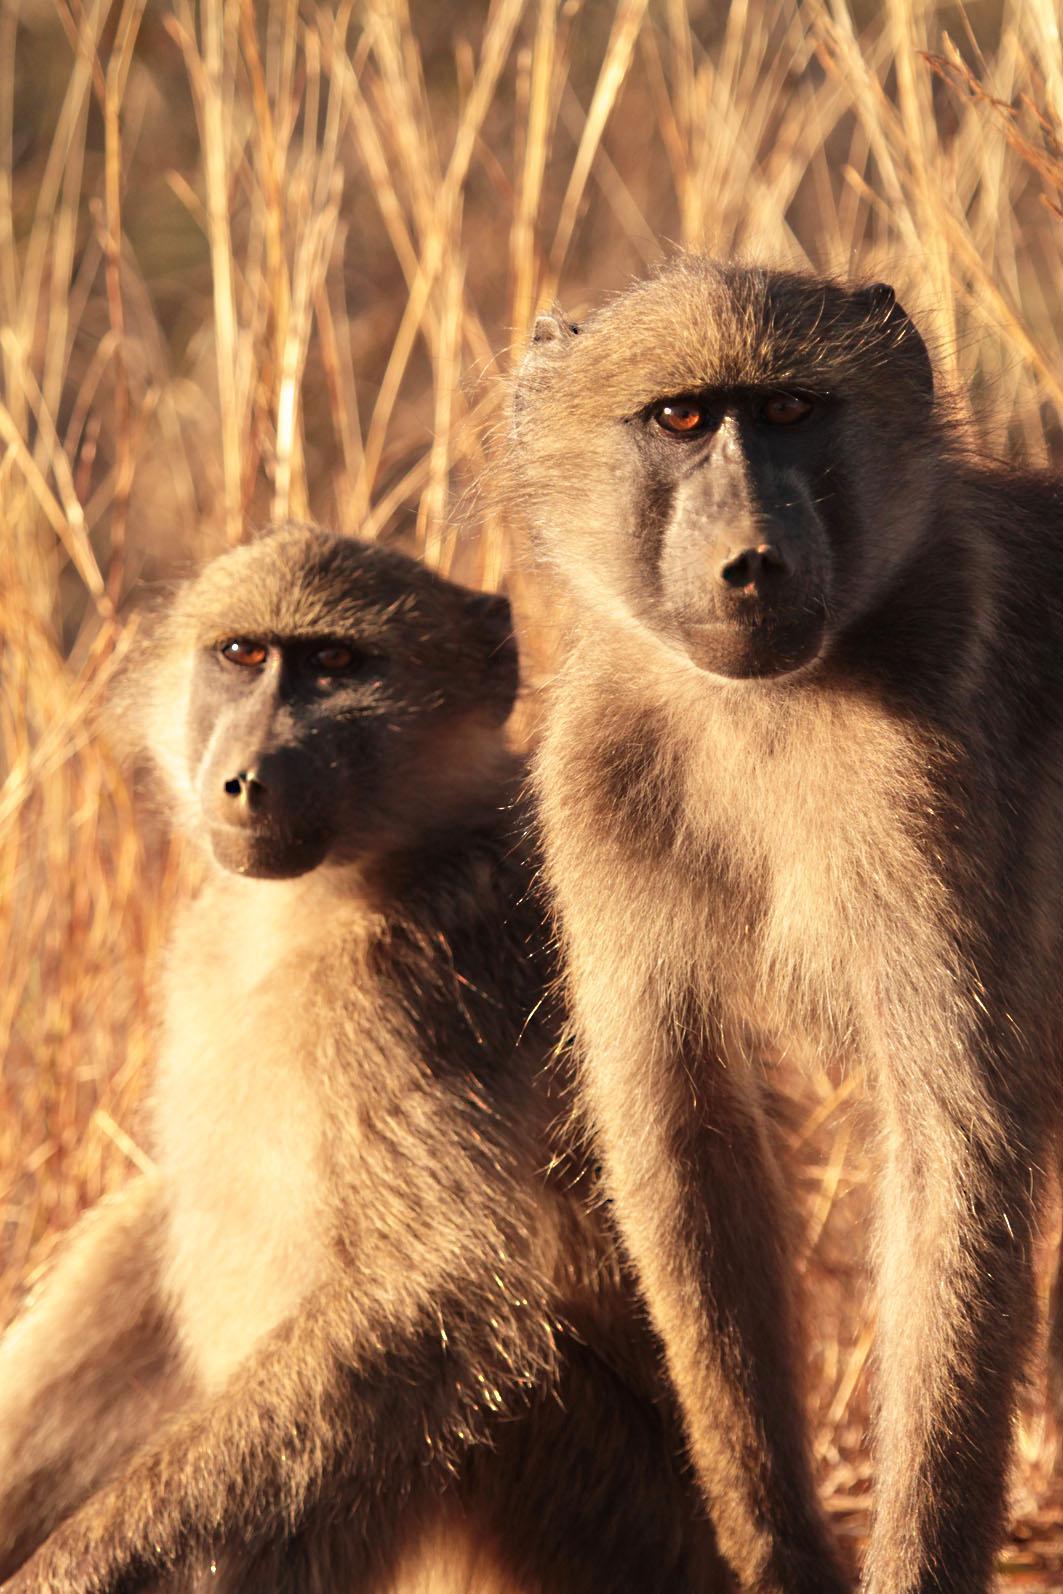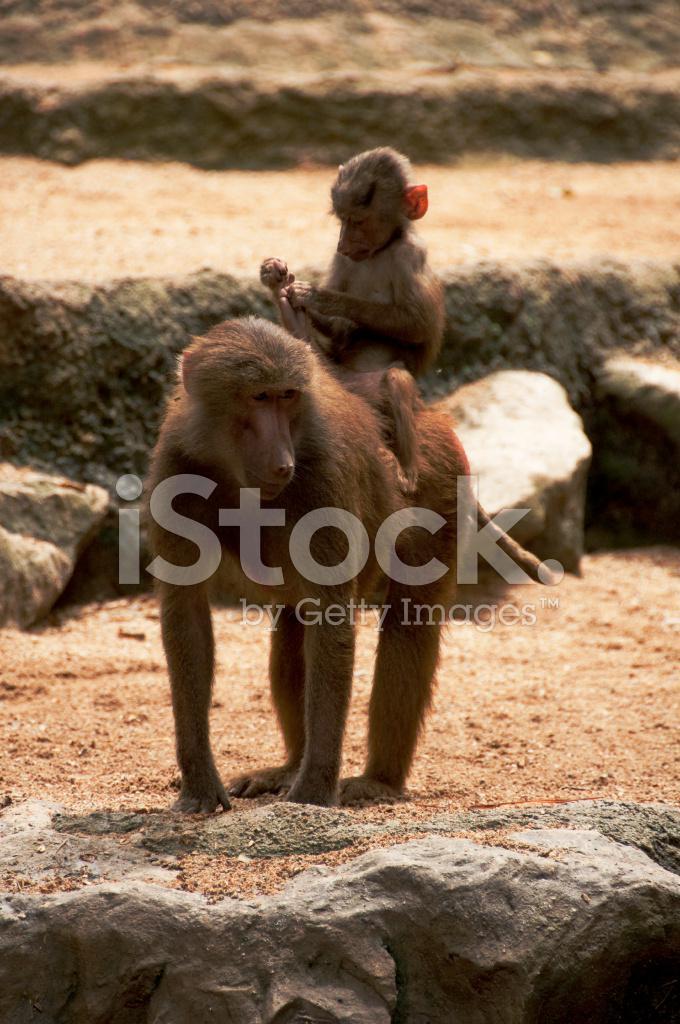The first image is the image on the left, the second image is the image on the right. Analyze the images presented: Is the assertion "At least one baboon is on the back of an animal bigger than itself, and no image contains more than two baboons." valid? Answer yes or no. Yes. The first image is the image on the left, the second image is the image on the right. Evaluate the accuracy of this statement regarding the images: "There are more primates in the image on the right.". Is it true? Answer yes or no. No. 